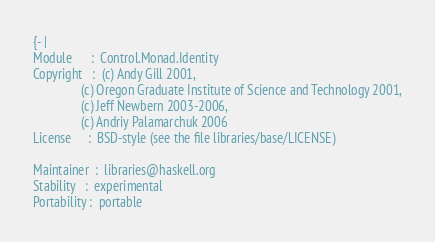<code> <loc_0><loc_0><loc_500><loc_500><_Haskell_>{- |
Module      :  Control.Monad.Identity
Copyright   :  (c) Andy Gill 2001,
               (c) Oregon Graduate Institute of Science and Technology 2001,
               (c) Jeff Newbern 2003-2006,
               (c) Andriy Palamarchuk 2006
License     :  BSD-style (see the file libraries/base/LICENSE)

Maintainer  :  libraries@haskell.org
Stability   :  experimental
Portability :  portable
</code> 